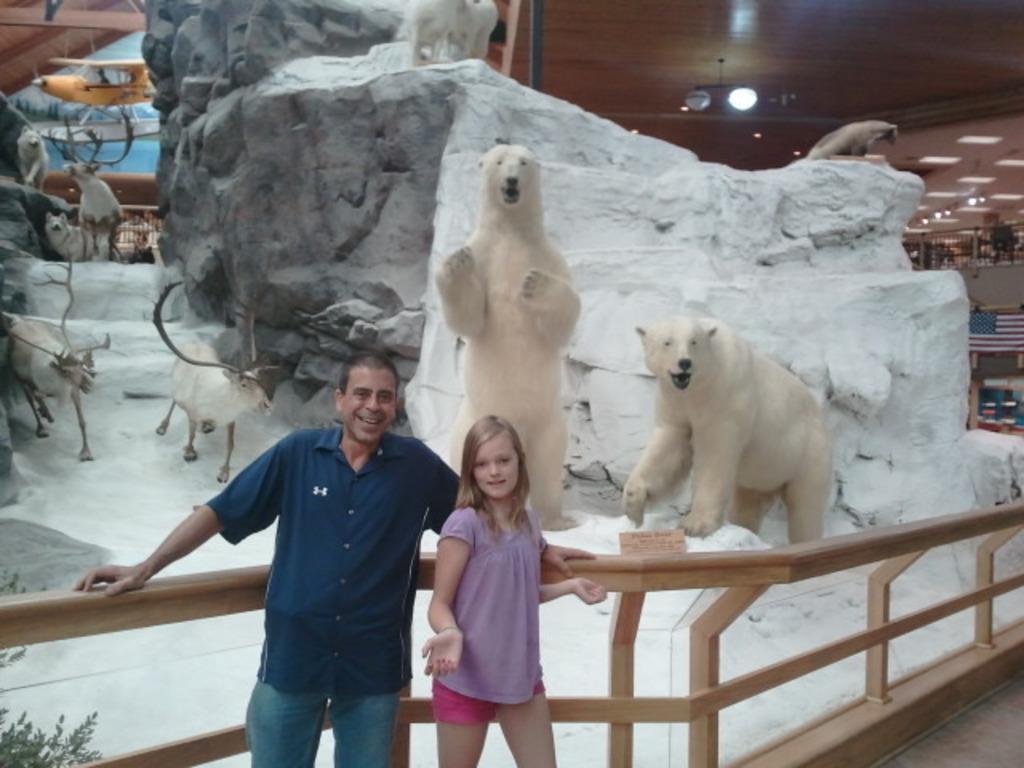Describe this image in one or two sentences. In the image there is a man with blue shirt is standing and beside her there is a girl is also standing. Behind them there is a wooden fencing. In the background there are statues of polar bears, reindeers and stones with white painting. 